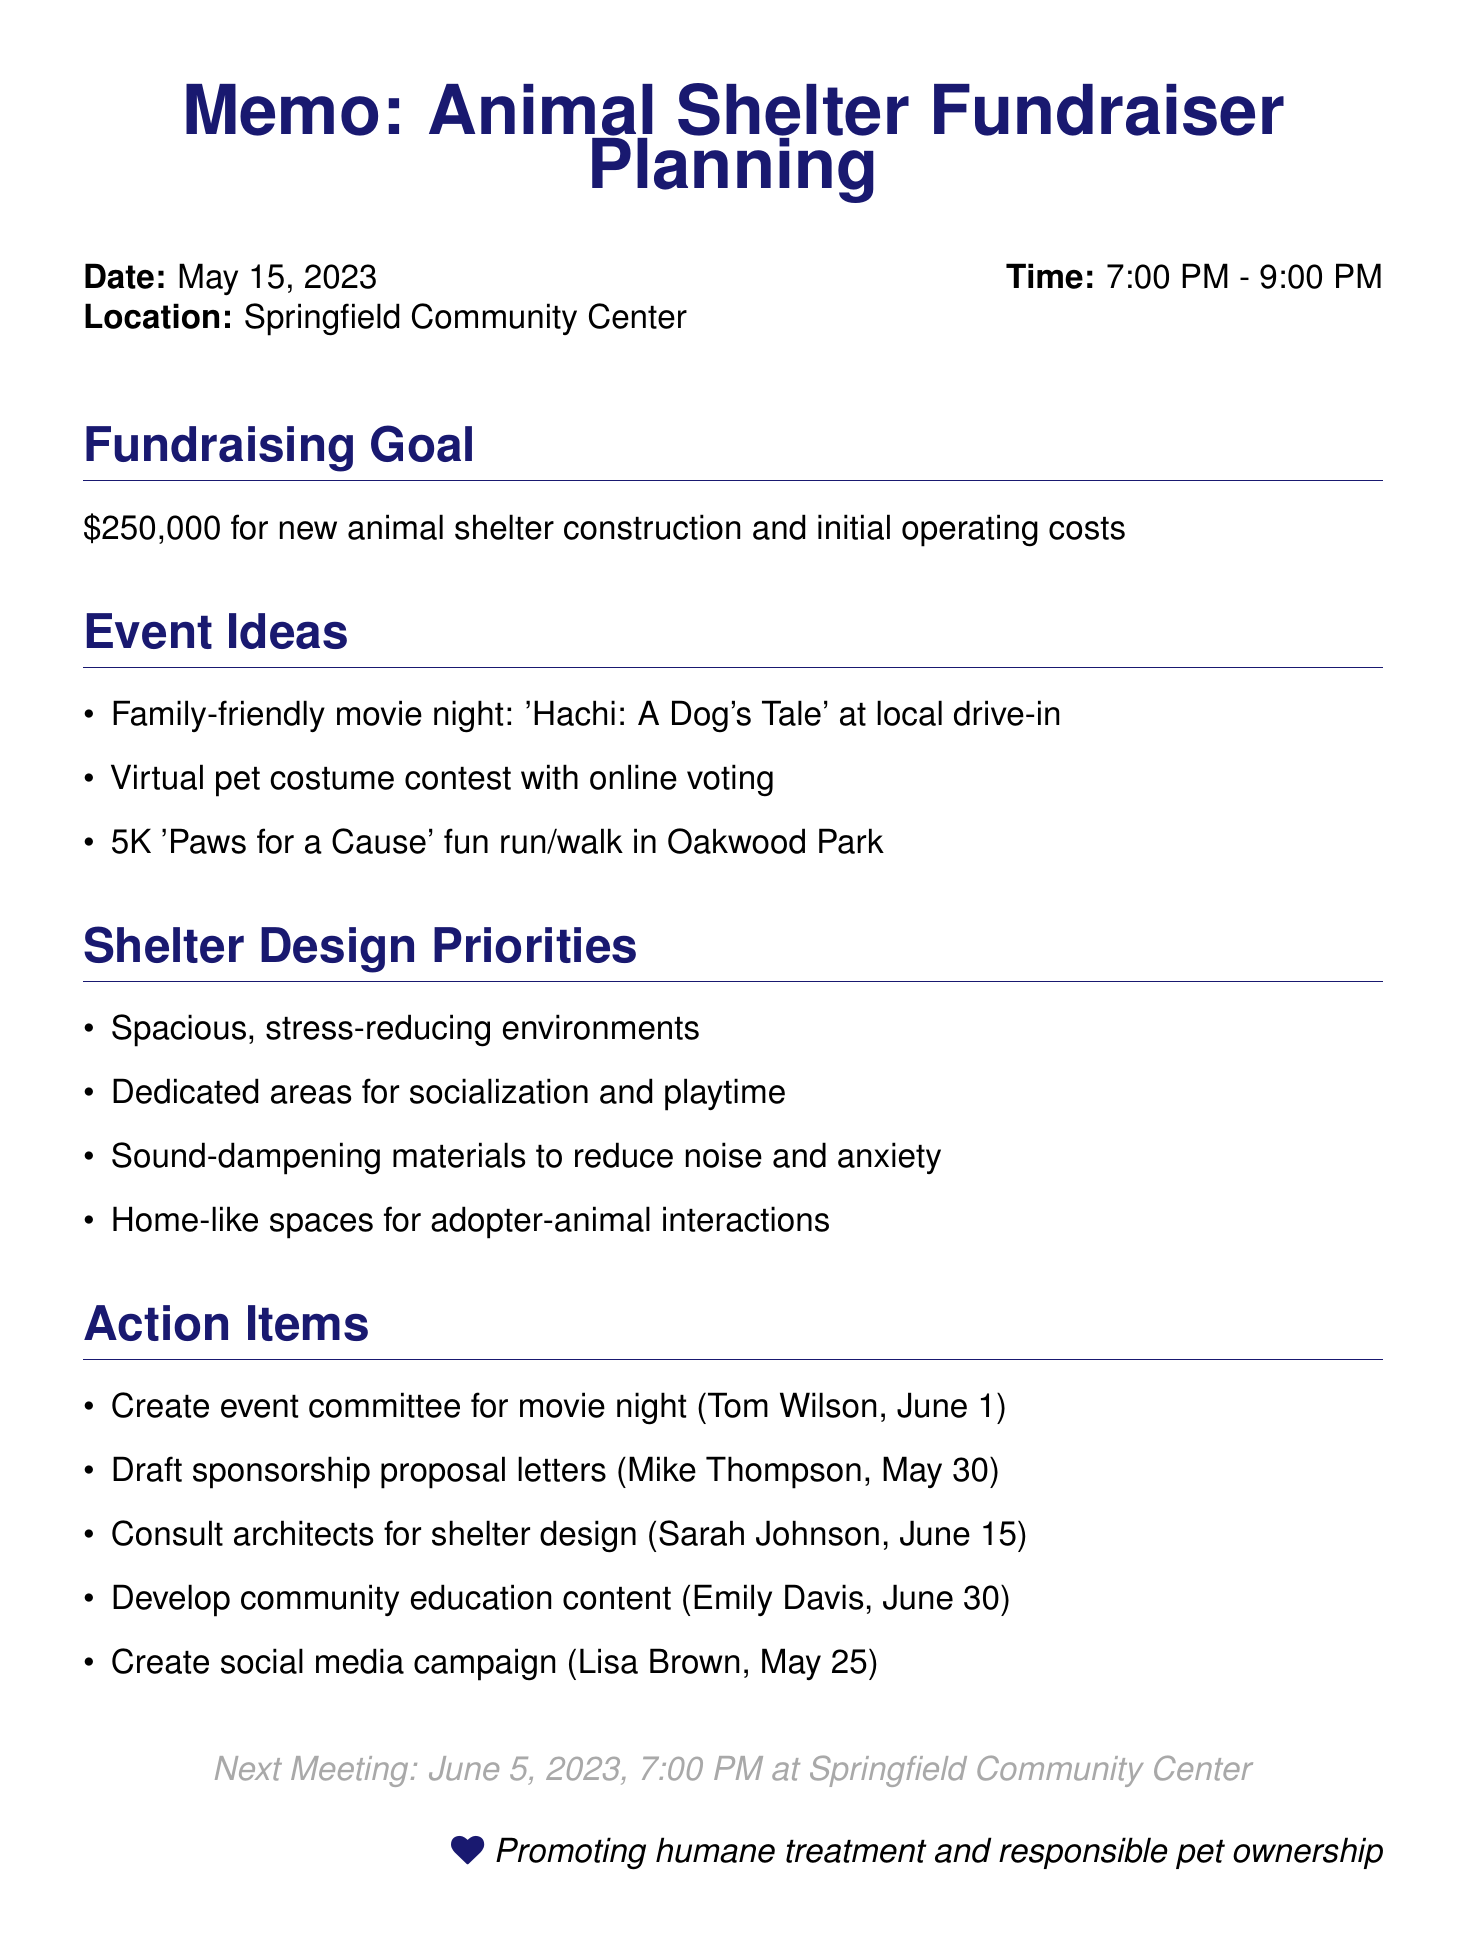What is the fundraising goal? The fundraising goal is identified in the agenda under "Fundraising Goal", which mentions a target amount for the animal shelter.
Answer: $250,000 What is one idea proposed for a fundraising event? The agenda item "Event Ideas" lists several options, including a family-friendly movie night.
Answer: Family-friendly movie night Who is responsible for drafting sponsorship proposal letters? The action item assigned indicates who is responsible and when it is due.
Answer: Mike Thompson What is the deadline for creating a social media campaign? Each action item includes an assigned person and a corresponding deadline, which is specified in the document.
Answer: May 25, 2023 What is one priority for shelter design? The "Shelter Design Priorities" section highlights several important design aspects for the animal shelter.
Answer: Spacious, stress-reducing environments How will community education be supported according to the memo? The "Community Education" section outlines plans for workshops and information dissemination regarding responsible pet ownership.
Answer: Workshops on animal care When is the next meeting scheduled? The next meeting date is specifically noted at the end of the memo for future reference.
Answer: June 5, 2023 Which movie is suggested for the family-friendly event? One of the event ideas specifically mentions a memorable movie relating to animals.
Answer: Hachi: A Dog's Tale 